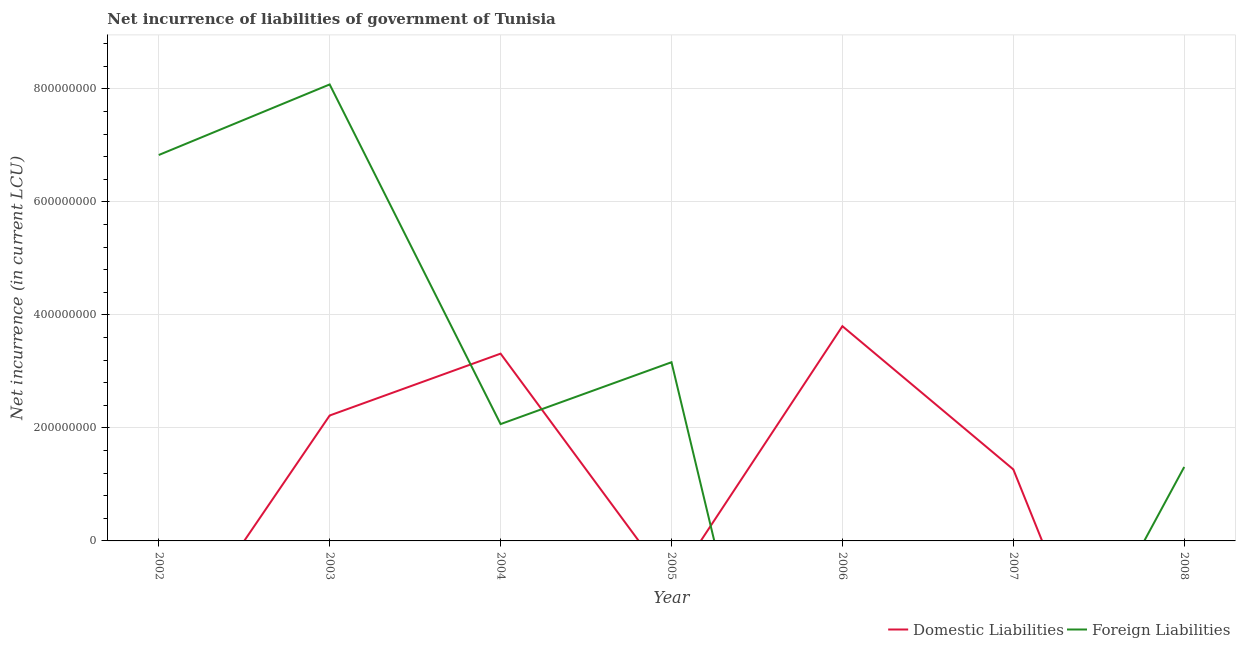How many different coloured lines are there?
Ensure brevity in your answer.  2. Does the line corresponding to net incurrence of domestic liabilities intersect with the line corresponding to net incurrence of foreign liabilities?
Provide a succinct answer. Yes. What is the net incurrence of foreign liabilities in 2008?
Make the answer very short. 1.31e+08. Across all years, what is the maximum net incurrence of foreign liabilities?
Your answer should be compact. 8.08e+08. Across all years, what is the minimum net incurrence of foreign liabilities?
Give a very brief answer. 0. What is the total net incurrence of foreign liabilities in the graph?
Your answer should be very brief. 2.15e+09. What is the difference between the net incurrence of foreign liabilities in 2003 and that in 2005?
Your response must be concise. 4.92e+08. What is the difference between the net incurrence of domestic liabilities in 2004 and the net incurrence of foreign liabilities in 2006?
Offer a very short reply. 3.32e+08. What is the average net incurrence of domestic liabilities per year?
Your answer should be compact. 1.51e+08. In the year 2004, what is the difference between the net incurrence of domestic liabilities and net incurrence of foreign liabilities?
Your answer should be compact. 1.25e+08. What is the ratio of the net incurrence of foreign liabilities in 2004 to that in 2008?
Your answer should be compact. 1.58. Is the net incurrence of domestic liabilities in 2003 less than that in 2007?
Offer a very short reply. No. What is the difference between the highest and the second highest net incurrence of domestic liabilities?
Offer a very short reply. 4.86e+07. What is the difference between the highest and the lowest net incurrence of domestic liabilities?
Your answer should be very brief. 3.80e+08. In how many years, is the net incurrence of domestic liabilities greater than the average net incurrence of domestic liabilities taken over all years?
Make the answer very short. 3. Does the net incurrence of foreign liabilities monotonically increase over the years?
Ensure brevity in your answer.  No. Is the net incurrence of domestic liabilities strictly greater than the net incurrence of foreign liabilities over the years?
Your response must be concise. No. How many lines are there?
Provide a succinct answer. 2. Where does the legend appear in the graph?
Provide a succinct answer. Bottom right. How many legend labels are there?
Your response must be concise. 2. What is the title of the graph?
Your answer should be very brief. Net incurrence of liabilities of government of Tunisia. Does "Overweight" appear as one of the legend labels in the graph?
Your response must be concise. No. What is the label or title of the X-axis?
Make the answer very short. Year. What is the label or title of the Y-axis?
Ensure brevity in your answer.  Net incurrence (in current LCU). What is the Net incurrence (in current LCU) in Foreign Liabilities in 2002?
Provide a short and direct response. 6.83e+08. What is the Net incurrence (in current LCU) in Domestic Liabilities in 2003?
Keep it short and to the point. 2.22e+08. What is the Net incurrence (in current LCU) in Foreign Liabilities in 2003?
Give a very brief answer. 8.08e+08. What is the Net incurrence (in current LCU) in Domestic Liabilities in 2004?
Provide a short and direct response. 3.32e+08. What is the Net incurrence (in current LCU) of Foreign Liabilities in 2004?
Offer a terse response. 2.07e+08. What is the Net incurrence (in current LCU) of Foreign Liabilities in 2005?
Your answer should be very brief. 3.16e+08. What is the Net incurrence (in current LCU) in Domestic Liabilities in 2006?
Keep it short and to the point. 3.80e+08. What is the Net incurrence (in current LCU) of Foreign Liabilities in 2006?
Offer a terse response. 0. What is the Net incurrence (in current LCU) in Domestic Liabilities in 2007?
Offer a very short reply. 1.27e+08. What is the Net incurrence (in current LCU) in Foreign Liabilities in 2007?
Your answer should be very brief. 0. What is the Net incurrence (in current LCU) in Domestic Liabilities in 2008?
Make the answer very short. 0. What is the Net incurrence (in current LCU) in Foreign Liabilities in 2008?
Your answer should be very brief. 1.31e+08. Across all years, what is the maximum Net incurrence (in current LCU) of Domestic Liabilities?
Your answer should be very brief. 3.80e+08. Across all years, what is the maximum Net incurrence (in current LCU) of Foreign Liabilities?
Offer a very short reply. 8.08e+08. What is the total Net incurrence (in current LCU) of Domestic Liabilities in the graph?
Provide a short and direct response. 1.06e+09. What is the total Net incurrence (in current LCU) in Foreign Liabilities in the graph?
Your answer should be very brief. 2.15e+09. What is the difference between the Net incurrence (in current LCU) of Foreign Liabilities in 2002 and that in 2003?
Your response must be concise. -1.25e+08. What is the difference between the Net incurrence (in current LCU) in Foreign Liabilities in 2002 and that in 2004?
Keep it short and to the point. 4.76e+08. What is the difference between the Net incurrence (in current LCU) in Foreign Liabilities in 2002 and that in 2005?
Your answer should be very brief. 3.67e+08. What is the difference between the Net incurrence (in current LCU) of Foreign Liabilities in 2002 and that in 2008?
Give a very brief answer. 5.52e+08. What is the difference between the Net incurrence (in current LCU) of Domestic Liabilities in 2003 and that in 2004?
Your answer should be very brief. -1.10e+08. What is the difference between the Net incurrence (in current LCU) of Foreign Liabilities in 2003 and that in 2004?
Give a very brief answer. 6.01e+08. What is the difference between the Net incurrence (in current LCU) in Foreign Liabilities in 2003 and that in 2005?
Your answer should be compact. 4.92e+08. What is the difference between the Net incurrence (in current LCU) of Domestic Liabilities in 2003 and that in 2006?
Your answer should be very brief. -1.58e+08. What is the difference between the Net incurrence (in current LCU) in Domestic Liabilities in 2003 and that in 2007?
Provide a short and direct response. 9.54e+07. What is the difference between the Net incurrence (in current LCU) in Foreign Liabilities in 2003 and that in 2008?
Make the answer very short. 6.77e+08. What is the difference between the Net incurrence (in current LCU) in Foreign Liabilities in 2004 and that in 2005?
Offer a terse response. -1.10e+08. What is the difference between the Net incurrence (in current LCU) of Domestic Liabilities in 2004 and that in 2006?
Your answer should be very brief. -4.86e+07. What is the difference between the Net incurrence (in current LCU) in Domestic Liabilities in 2004 and that in 2007?
Offer a terse response. 2.05e+08. What is the difference between the Net incurrence (in current LCU) in Foreign Liabilities in 2004 and that in 2008?
Offer a terse response. 7.59e+07. What is the difference between the Net incurrence (in current LCU) of Foreign Liabilities in 2005 and that in 2008?
Offer a terse response. 1.85e+08. What is the difference between the Net incurrence (in current LCU) in Domestic Liabilities in 2006 and that in 2007?
Make the answer very short. 2.54e+08. What is the difference between the Net incurrence (in current LCU) in Domestic Liabilities in 2003 and the Net incurrence (in current LCU) in Foreign Liabilities in 2004?
Make the answer very short. 1.52e+07. What is the difference between the Net incurrence (in current LCU) in Domestic Liabilities in 2003 and the Net incurrence (in current LCU) in Foreign Liabilities in 2005?
Provide a short and direct response. -9.43e+07. What is the difference between the Net incurrence (in current LCU) of Domestic Liabilities in 2003 and the Net incurrence (in current LCU) of Foreign Liabilities in 2008?
Your answer should be very brief. 9.11e+07. What is the difference between the Net incurrence (in current LCU) of Domestic Liabilities in 2004 and the Net incurrence (in current LCU) of Foreign Liabilities in 2005?
Offer a terse response. 1.52e+07. What is the difference between the Net incurrence (in current LCU) in Domestic Liabilities in 2004 and the Net incurrence (in current LCU) in Foreign Liabilities in 2008?
Your answer should be compact. 2.01e+08. What is the difference between the Net incurrence (in current LCU) in Domestic Liabilities in 2006 and the Net incurrence (in current LCU) in Foreign Liabilities in 2008?
Offer a terse response. 2.49e+08. What is the difference between the Net incurrence (in current LCU) of Domestic Liabilities in 2007 and the Net incurrence (in current LCU) of Foreign Liabilities in 2008?
Give a very brief answer. -4.30e+06. What is the average Net incurrence (in current LCU) in Domestic Liabilities per year?
Give a very brief answer. 1.51e+08. What is the average Net incurrence (in current LCU) in Foreign Liabilities per year?
Give a very brief answer. 3.06e+08. In the year 2003, what is the difference between the Net incurrence (in current LCU) of Domestic Liabilities and Net incurrence (in current LCU) of Foreign Liabilities?
Ensure brevity in your answer.  -5.86e+08. In the year 2004, what is the difference between the Net incurrence (in current LCU) of Domestic Liabilities and Net incurrence (in current LCU) of Foreign Liabilities?
Your answer should be very brief. 1.25e+08. What is the ratio of the Net incurrence (in current LCU) in Foreign Liabilities in 2002 to that in 2003?
Provide a short and direct response. 0.85. What is the ratio of the Net incurrence (in current LCU) of Foreign Liabilities in 2002 to that in 2004?
Give a very brief answer. 3.3. What is the ratio of the Net incurrence (in current LCU) of Foreign Liabilities in 2002 to that in 2005?
Make the answer very short. 2.16. What is the ratio of the Net incurrence (in current LCU) of Foreign Liabilities in 2002 to that in 2008?
Give a very brief answer. 5.22. What is the ratio of the Net incurrence (in current LCU) in Domestic Liabilities in 2003 to that in 2004?
Provide a short and direct response. 0.67. What is the ratio of the Net incurrence (in current LCU) in Foreign Liabilities in 2003 to that in 2004?
Make the answer very short. 3.91. What is the ratio of the Net incurrence (in current LCU) of Foreign Liabilities in 2003 to that in 2005?
Your answer should be compact. 2.55. What is the ratio of the Net incurrence (in current LCU) in Domestic Liabilities in 2003 to that in 2006?
Give a very brief answer. 0.58. What is the ratio of the Net incurrence (in current LCU) of Domestic Liabilities in 2003 to that in 2007?
Your answer should be compact. 1.75. What is the ratio of the Net incurrence (in current LCU) of Foreign Liabilities in 2003 to that in 2008?
Your answer should be compact. 6.17. What is the ratio of the Net incurrence (in current LCU) of Foreign Liabilities in 2004 to that in 2005?
Provide a succinct answer. 0.65. What is the ratio of the Net incurrence (in current LCU) in Domestic Liabilities in 2004 to that in 2006?
Provide a short and direct response. 0.87. What is the ratio of the Net incurrence (in current LCU) of Domestic Liabilities in 2004 to that in 2007?
Give a very brief answer. 2.62. What is the ratio of the Net incurrence (in current LCU) of Foreign Liabilities in 2004 to that in 2008?
Your answer should be compact. 1.58. What is the ratio of the Net incurrence (in current LCU) in Foreign Liabilities in 2005 to that in 2008?
Provide a succinct answer. 2.42. What is the ratio of the Net incurrence (in current LCU) in Domestic Liabilities in 2006 to that in 2007?
Provide a short and direct response. 3. What is the difference between the highest and the second highest Net incurrence (in current LCU) in Domestic Liabilities?
Your answer should be very brief. 4.86e+07. What is the difference between the highest and the second highest Net incurrence (in current LCU) in Foreign Liabilities?
Make the answer very short. 1.25e+08. What is the difference between the highest and the lowest Net incurrence (in current LCU) of Domestic Liabilities?
Ensure brevity in your answer.  3.80e+08. What is the difference between the highest and the lowest Net incurrence (in current LCU) in Foreign Liabilities?
Offer a very short reply. 8.08e+08. 